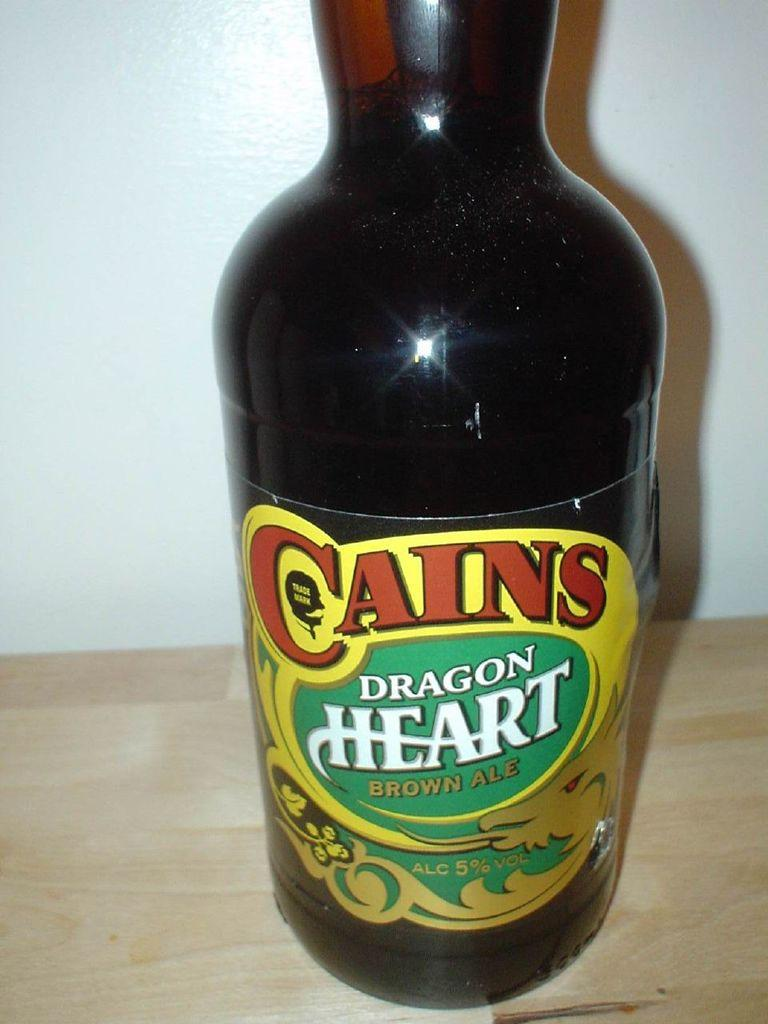Provide a one-sentence caption for the provided image. Cains Dragon Heart is a brown ale containing 5% alcohol. 